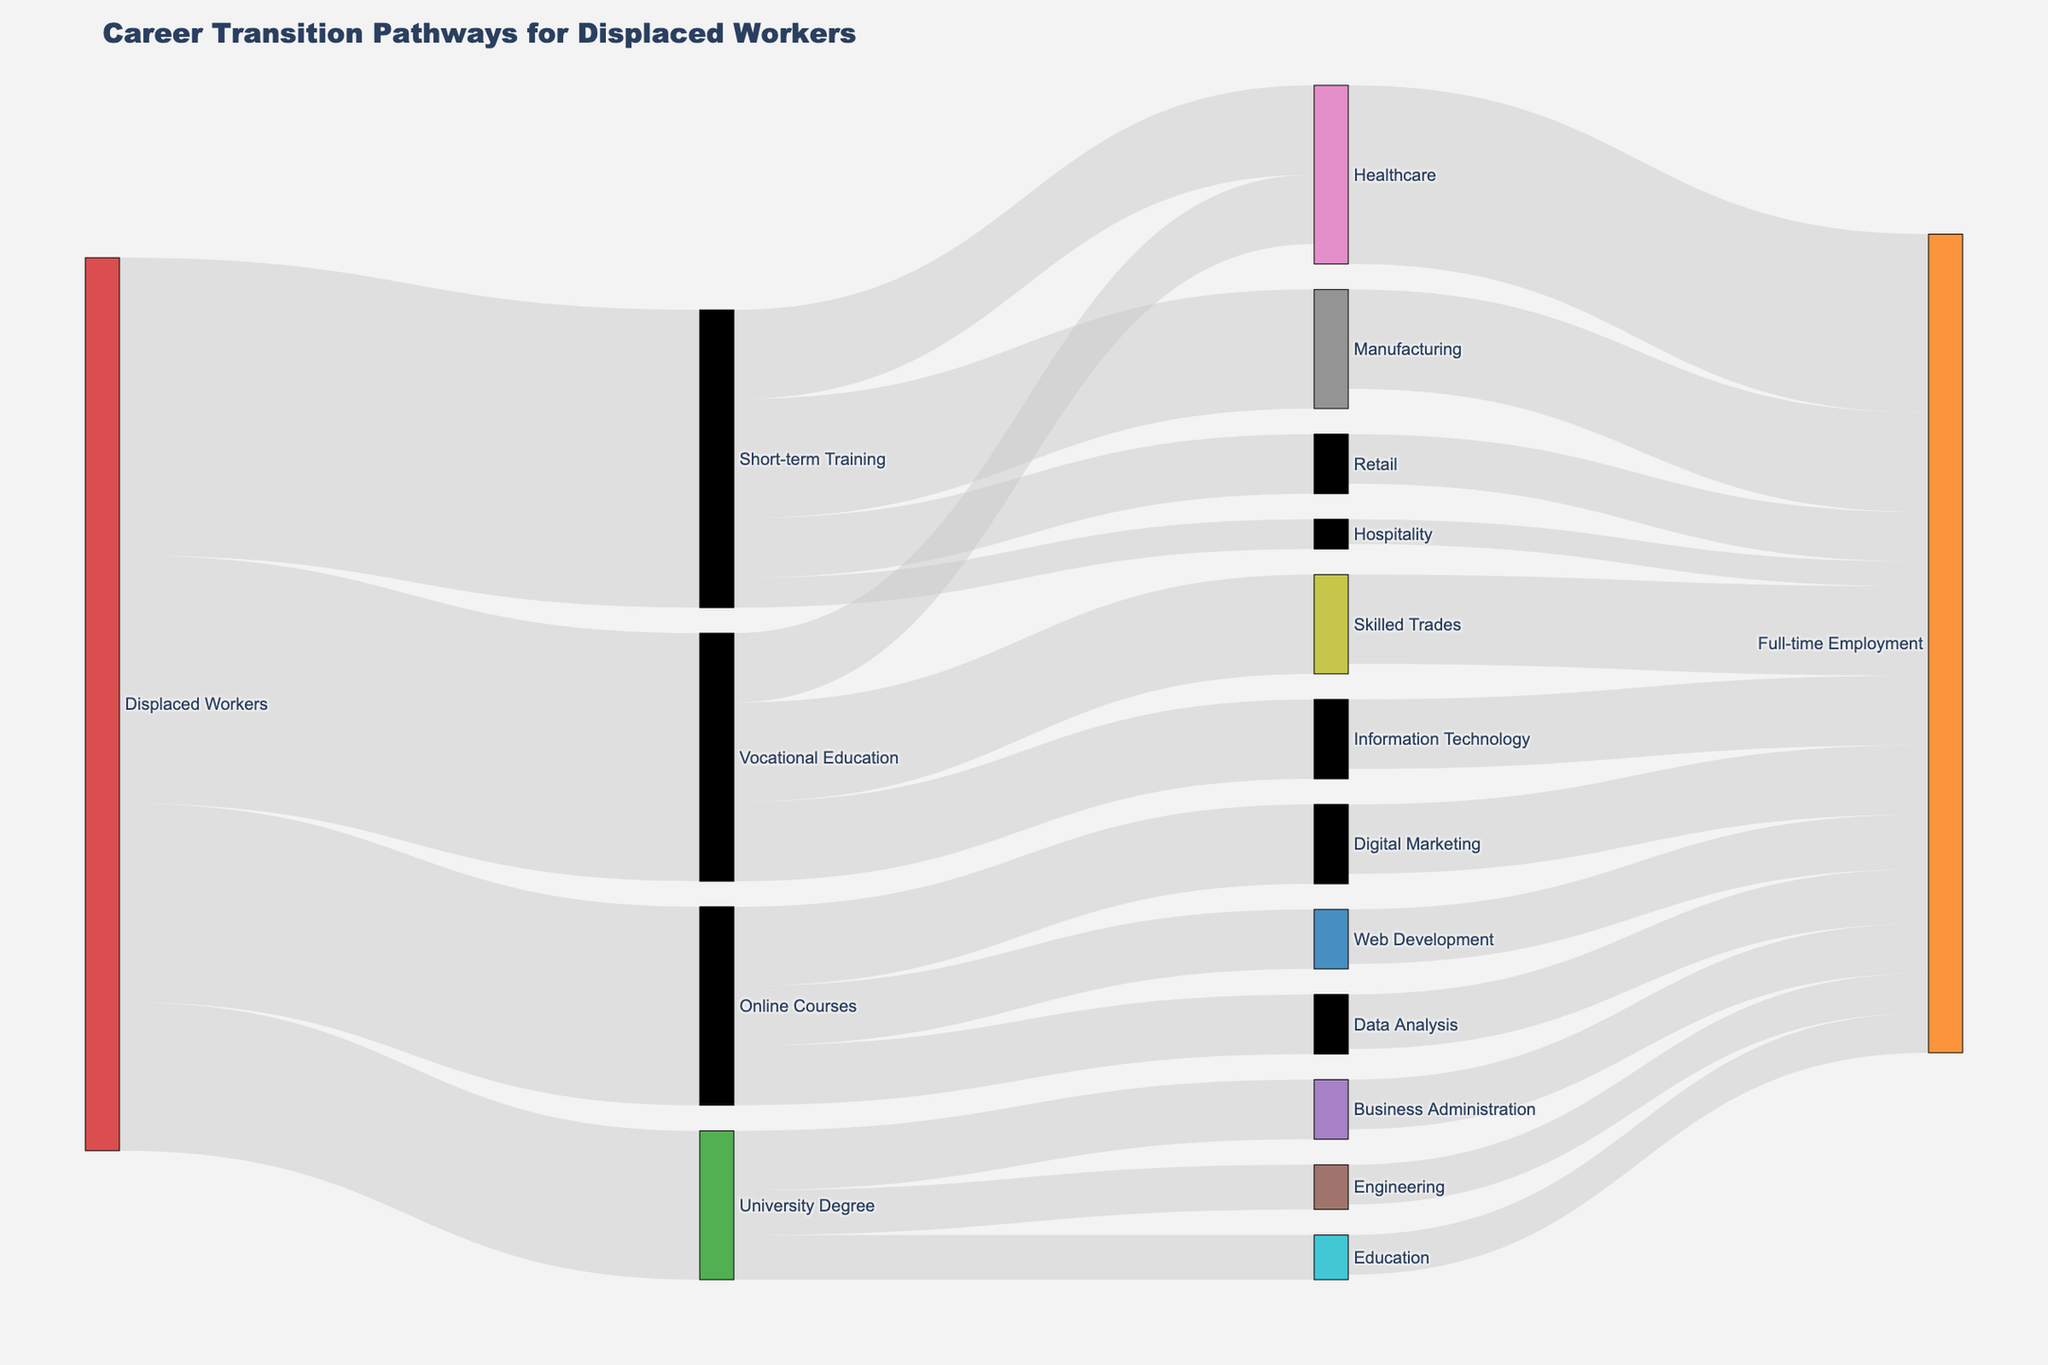What is the title of the figure? The title of the figure is stated at the top of the Sankey Diagram.
Answer: Career Transition Pathways for Displaced Workers How many people opted for short-term training? The figure shows a flow from 'Displaced Workers' to 'Short-term Training'. The value of this flow is indicated.
Answer: 3000 Which retraining option has the fewest displaced workers? By comparing the values connected from 'Displaced Workers' to each retraining option, we can identify the smallest value.
Answer: University Degree How many total people moved from vocational education into full-time employment? Summing up the values connected from 'Vocational Education' to various sectors shows how many people moved into full-time jobs.
Answer: 2400 Which career pathway resulted in the highest number of people obtaining full-time employment in healthcare? We trace the flows leading to 'Healthcare ➜ Full-time Employment' and compare the originating paths.
Answer: Short-term Training What is the combined number of people who pursued online courses and short-term training? Add the values connected from 'Displaced Workers' to both 'Online Courses' and 'Short-term Training'.
Answer: 5000 How does the number of displaced workers pursuing university degrees compare to those enrolling in online courses? Compare the values of 'Displaced Workers ➜ University Degree' and 'Displaced Workers ➜ Online Courses'.
Answer: Online Courses has more, with 2000 vs 1500 Which retraining option provides the most diverse range of sectors for full-time employment? By counting different sectors each retraining option leads to, we can find the one with the highest diversity.
Answer: Short-term Training (4 sectors) What is the total number of people who transitioned into healthcare as a sector? Combine the values from different retraining paths leading to 'Healthcare'.
Answer: 3400 Which retraining option leads to the second-highest full-time employment in the IT sector? Following paths leading to 'Information Technology ➜ Full-time Employment', then checking the primary paths from retraining options.
Answer: Vocational Education 